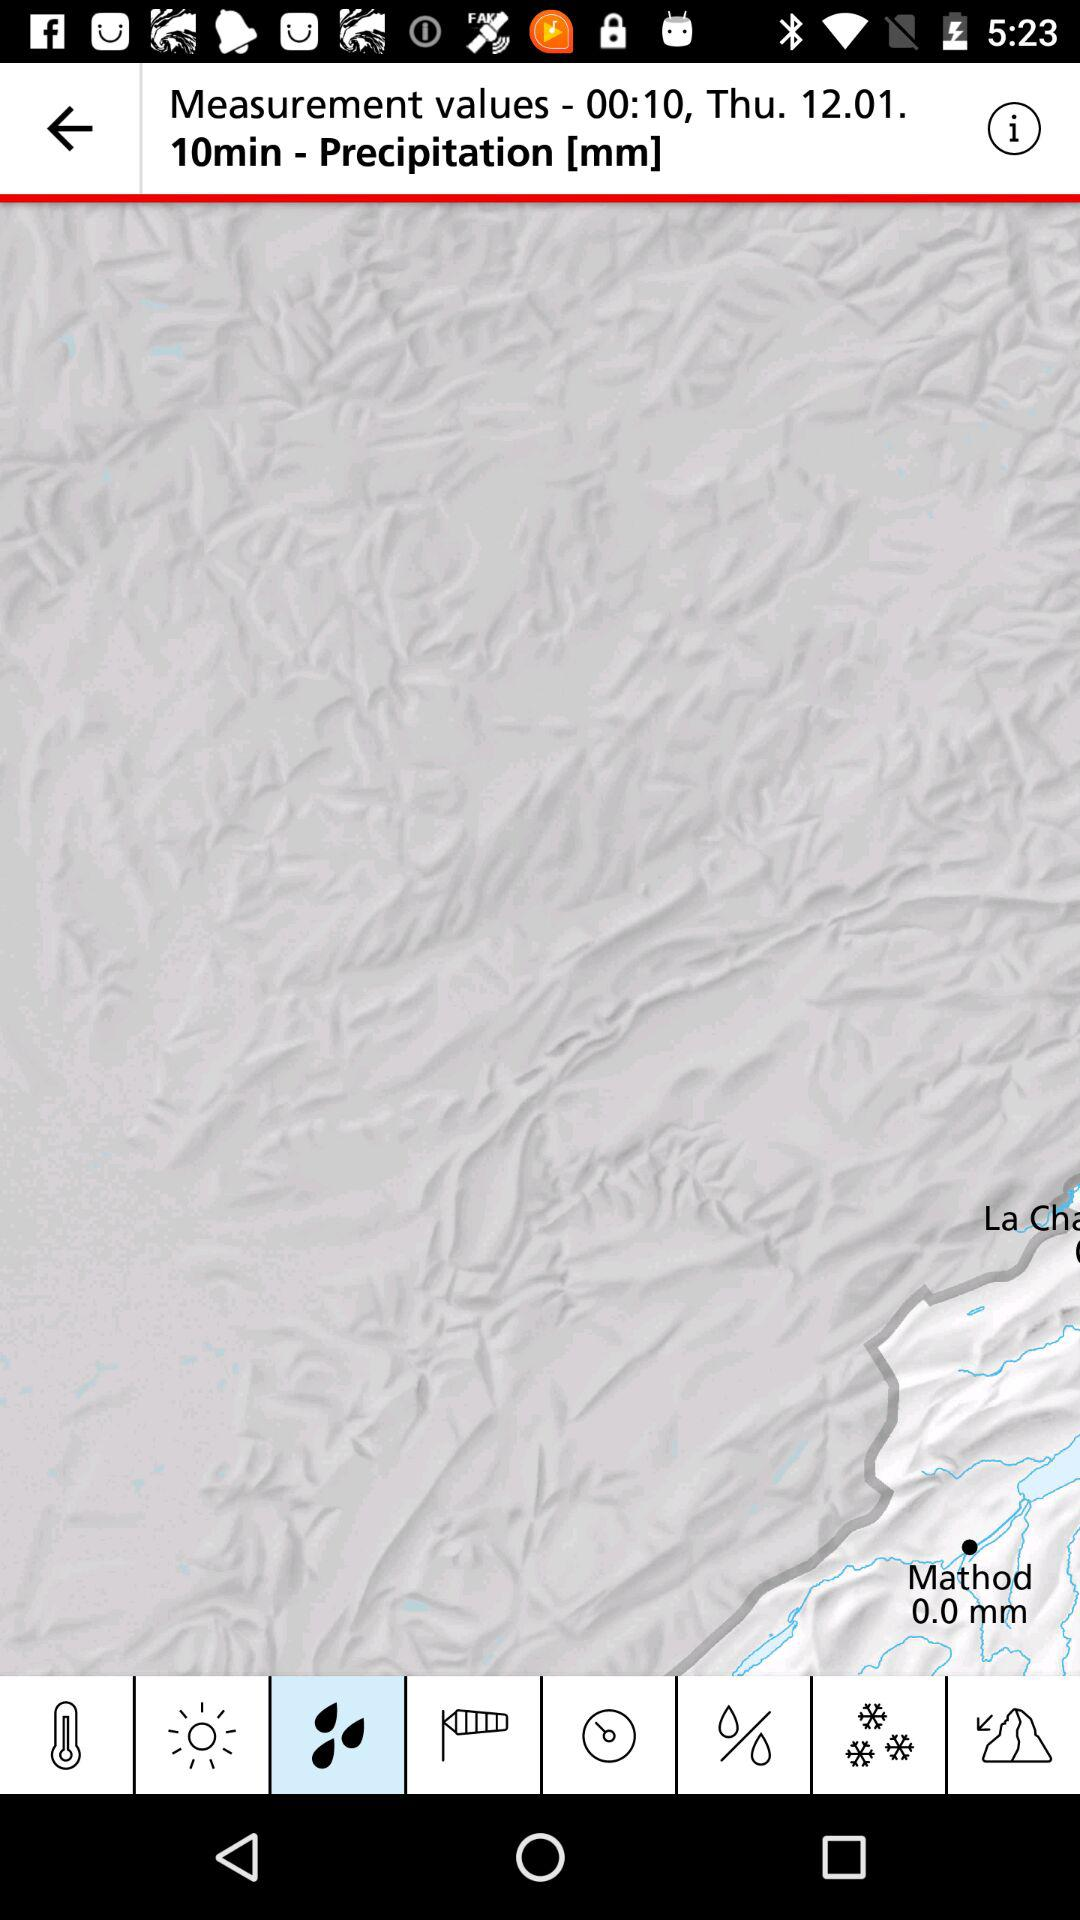What is the mentioned time? The mentioned time is 00:10. 